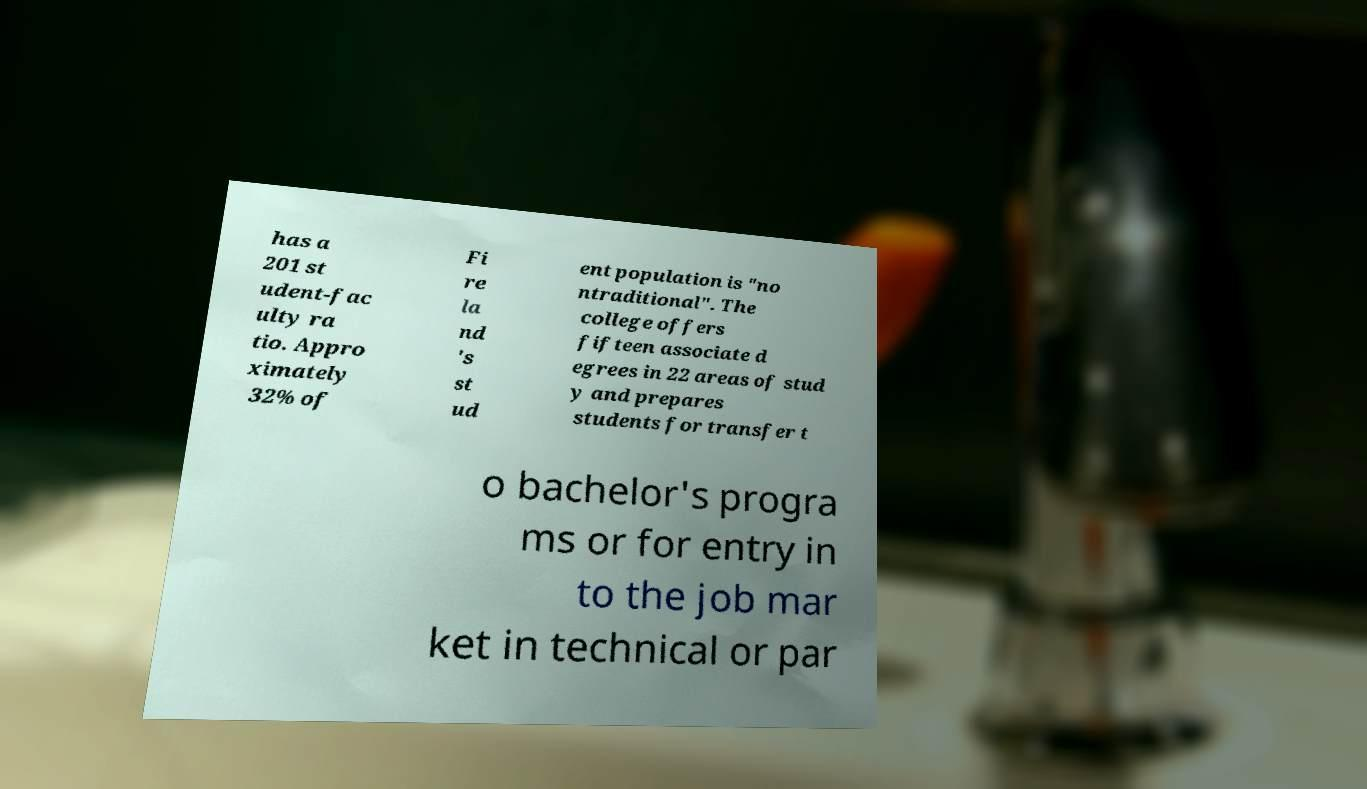Could you extract and type out the text from this image? has a 201 st udent-fac ulty ra tio. Appro ximately 32% of Fi re la nd 's st ud ent population is "no ntraditional". The college offers fifteen associate d egrees in 22 areas of stud y and prepares students for transfer t o bachelor's progra ms or for entry in to the job mar ket in technical or par 